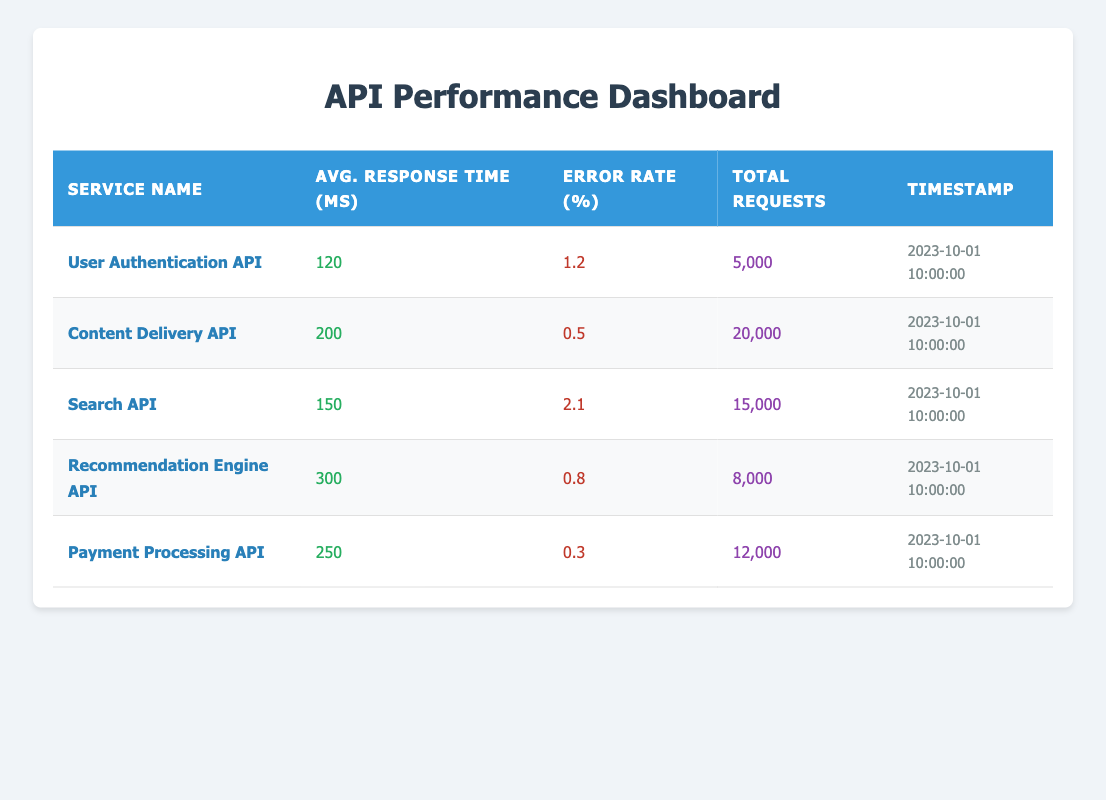What is the average response time for the User Authentication API? The data shows that the average response time for the User Authentication API is listed directly under "Avg. Response Time (ms)". The value there is 120 ms.
Answer: 120 ms Which API has the highest error rate? By comparing the "Error Rate (%)" column across all APIs, the Search API has the highest error rate at 2.1%.
Answer: Search API What is the total number of requests made to the Content Delivery API? The total requests for the Content Delivery API can be found in the "Total Requests" column, where the value is 20,000.
Answer: 20,000 What is the average response time across all APIs? To find the average response time, sum the average response times: (120 + 200 + 150 + 300 + 250) = 1020 ms, then divide by the number of APIs (5). Thus, the average is 1020/5 = 204 ms.
Answer: 204 ms Is the error rate for the Payment Processing API below 1%? The error rate for the Payment Processing API is 0.3%, which is indeed below 1%.
Answer: Yes Which API has more requests, Payment Processing API or Recommendation Engine API? The number of requests for the Payment Processing API is 12,000 and for the Recommendation Engine API is 8,000. Since 12,000 is greater than 8,000, the Payment Processing API has more requests.
Answer: Payment Processing API What is the total error rate for the User Authentication API and the Search API combined? The error rates for these APIs are 1.2% and 2.1%, respectively. To find the combined error rate for both APIs, add them together: 1.2 + 2.1 = 3.3%.
Answer: 3.3% Which API has the least error rate and what is that rate? By comparing the "Error Rate (%)" column, the Payment Processing API has the least error rate at 0.3%.
Answer: Payment Processing API, 0.3% What is the difference in average response time between the Search API and the Content Delivery API? The average response time for the Search API is 150 ms, and for the Content Delivery API, it is 200 ms. Thus, the difference is 200 - 150 = 50 ms.
Answer: 50 ms 